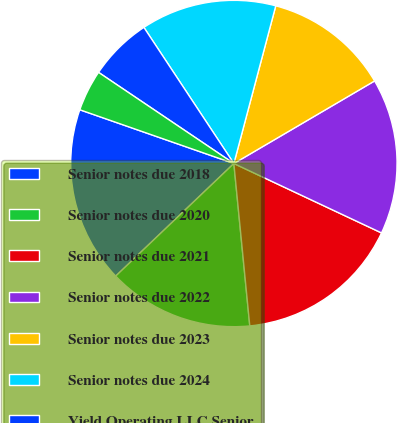<chart> <loc_0><loc_0><loc_500><loc_500><pie_chart><fcel>Senior notes due 2018<fcel>Senior notes due 2020<fcel>Senior notes due 2021<fcel>Senior notes due 2022<fcel>Senior notes due 2023<fcel>Senior notes due 2024<fcel>Yield Operating LLC Senior<fcel>Yield Inc Convertible Senior<nl><fcel>17.46%<fcel>14.44%<fcel>16.45%<fcel>15.44%<fcel>12.42%<fcel>13.43%<fcel>6.27%<fcel>4.09%<nl></chart> 